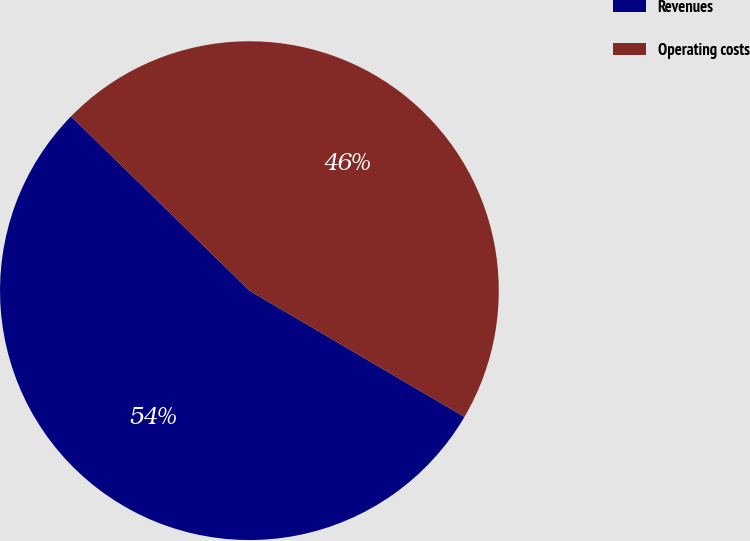Convert chart. <chart><loc_0><loc_0><loc_500><loc_500><pie_chart><fcel>Revenues<fcel>Operating costs<nl><fcel>53.87%<fcel>46.13%<nl></chart> 